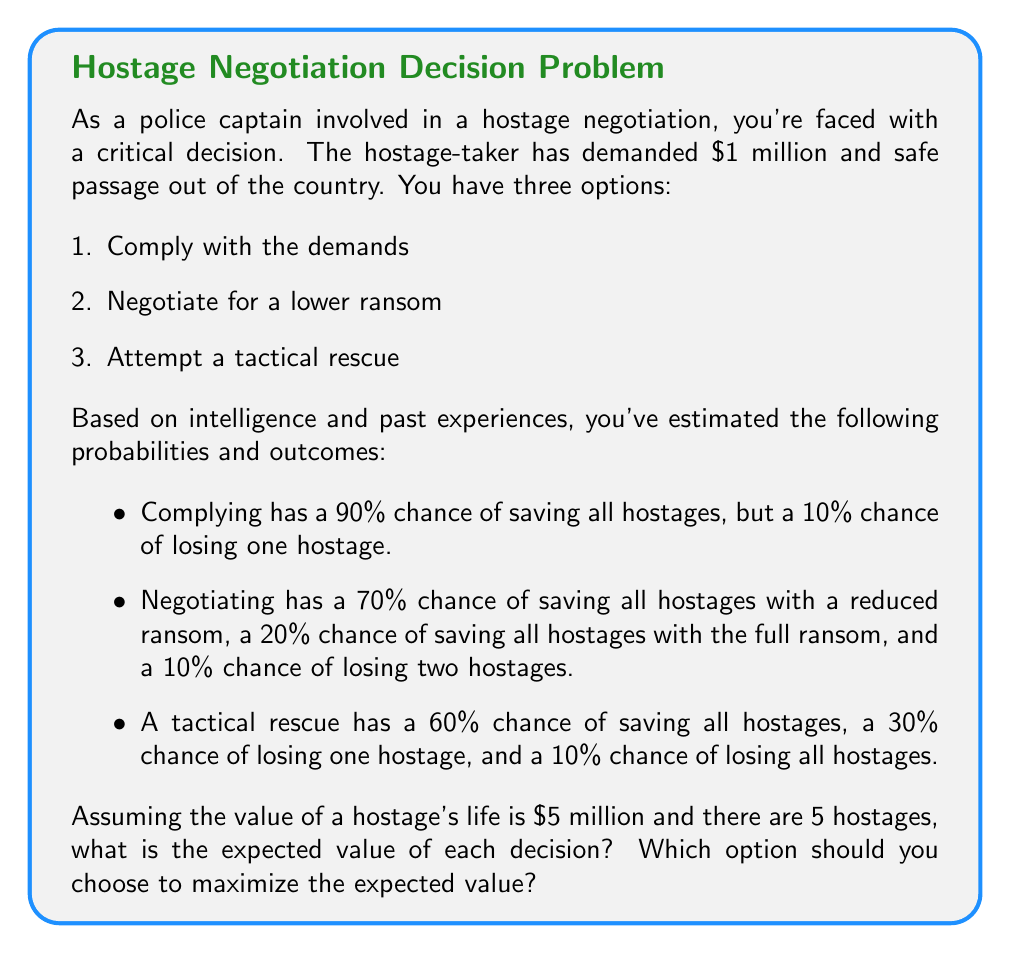Solve this math problem. Let's break this down step-by-step:

1) First, we need to calculate the expected value for each option. The expected value is the sum of each possible outcome multiplied by its probability.

2) For option 1 (Comply):
   $$EV_1 = 0.9 \times (5 \times \$5M - \$1M) + 0.1 \times (4 \times \$5M - \$1M)$$
   $$EV_1 = 0.9 \times \$24M + 0.1 \times \$19M$$
   $$EV_1 = \$21.6M + \$1.9M = \$23.5M$$

3) For option 2 (Negotiate):
   Let's assume the reduced ransom is half of the original, i.e., $0.5M.
   $$EV_2 = 0.7 \times (5 \times \$5M - \$0.5M) + 0.2 \times (5 \times \$5M - \$1M) + 0.1 \times (3 \times \$5M)$$
   $$EV_2 = 0.7 \times \$24.5M + 0.2 \times \$24M + 0.1 \times \$15M$$
   $$EV_2 = \$17.15M + \$4.8M + \$1.5M = \$23.45M$$

4) For option 3 (Tactical rescue):
   $$EV_3 = 0.6 \times (5 \times \$5M) + 0.3 \times (4 \times \$5M) + 0.1 \times 0$$
   $$EV_3 = 0.6 \times \$25M + 0.3 \times \$20M + 0$$
   $$EV_3 = \$15M + \$6M = \$21M$$

5) Comparing the expected values:
   $EV_1 = \$23.5M$
   $EV_2 = \$23.45M$
   $EV_3 = \$21M$

Therefore, to maximize the expected value, you should choose option 1: Comply with the demands.
Answer: The expected values are:
Option 1 (Comply): $23.5 million
Option 2 (Negotiate): $23.45 million
Option 3 (Tactical rescue): $21 million

To maximize the expected value, you should choose option 1: Comply with the demands. 